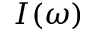Convert formula to latex. <formula><loc_0><loc_0><loc_500><loc_500>I ( \omega )</formula> 